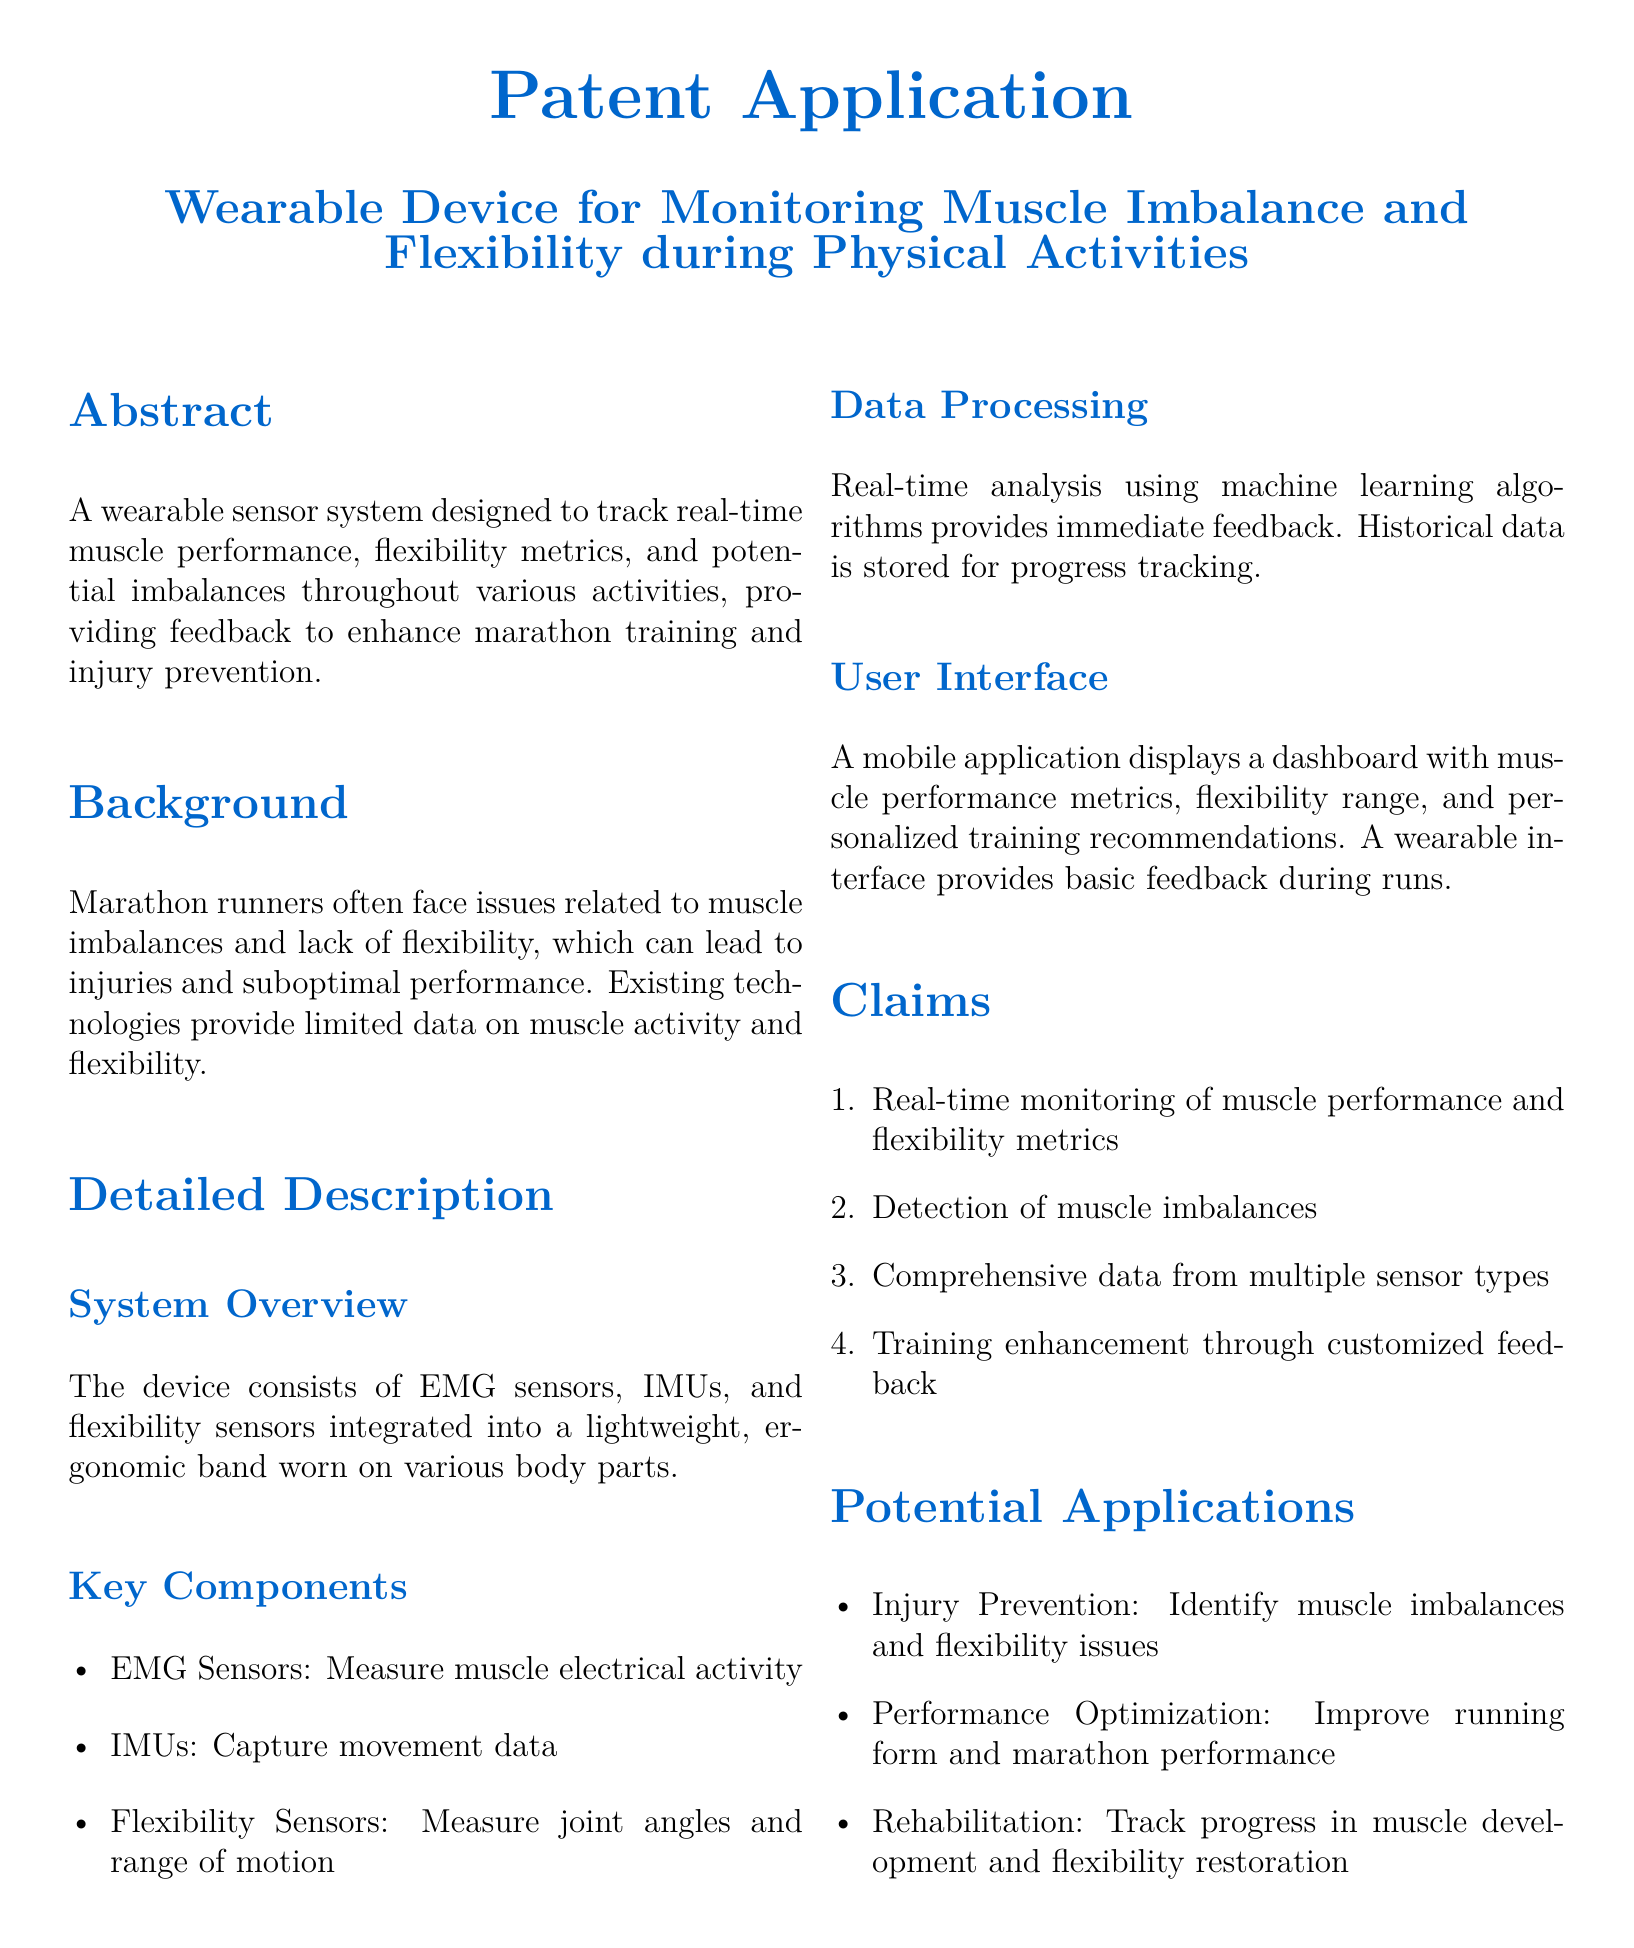What is the purpose of the wearable device? The purpose is to track real-time muscle performance, flexibility metrics, and potential imbalances during activities.
Answer: To track real-time muscle performance, flexibility metrics, and potential imbalances What technology is used to measure muscle activity? Muscle activity is measured using EMG sensors as specifically mentioned in the document.
Answer: EMG sensors Which metrics does the device aim to monitor? The device aims to monitor muscle performance and flexibility metrics throughout various activities.
Answer: Muscle performance and flexibility metrics What type of data does the device provide for training enhancement? The device provides customized feedback based on real-time data from multiple sensor types.
Answer: Customized feedback How many claims are listed in the patent application? The claims section includes a total of four specific claims regarding the device's functionality.
Answer: Four What is the significance of detecting muscle imbalances? Detecting muscle imbalances is critical for injury prevention and improving overall performance in runners.
Answer: Injury prevention Where can users view their muscle performance metrics? Users can view their muscle performance metrics through a mobile application dashboard provided by the system.
Answer: Mobile application What sensors are included in the wearable device? The device includes EMG sensors, IMUs, and flexibility sensors as stated in the key components section.
Answer: EMG sensors, IMUs, and flexibility sensors What is the historical data used for? Historical data is used for tracking progress in muscle performance and flexibility over time.
Answer: Progress tracking 